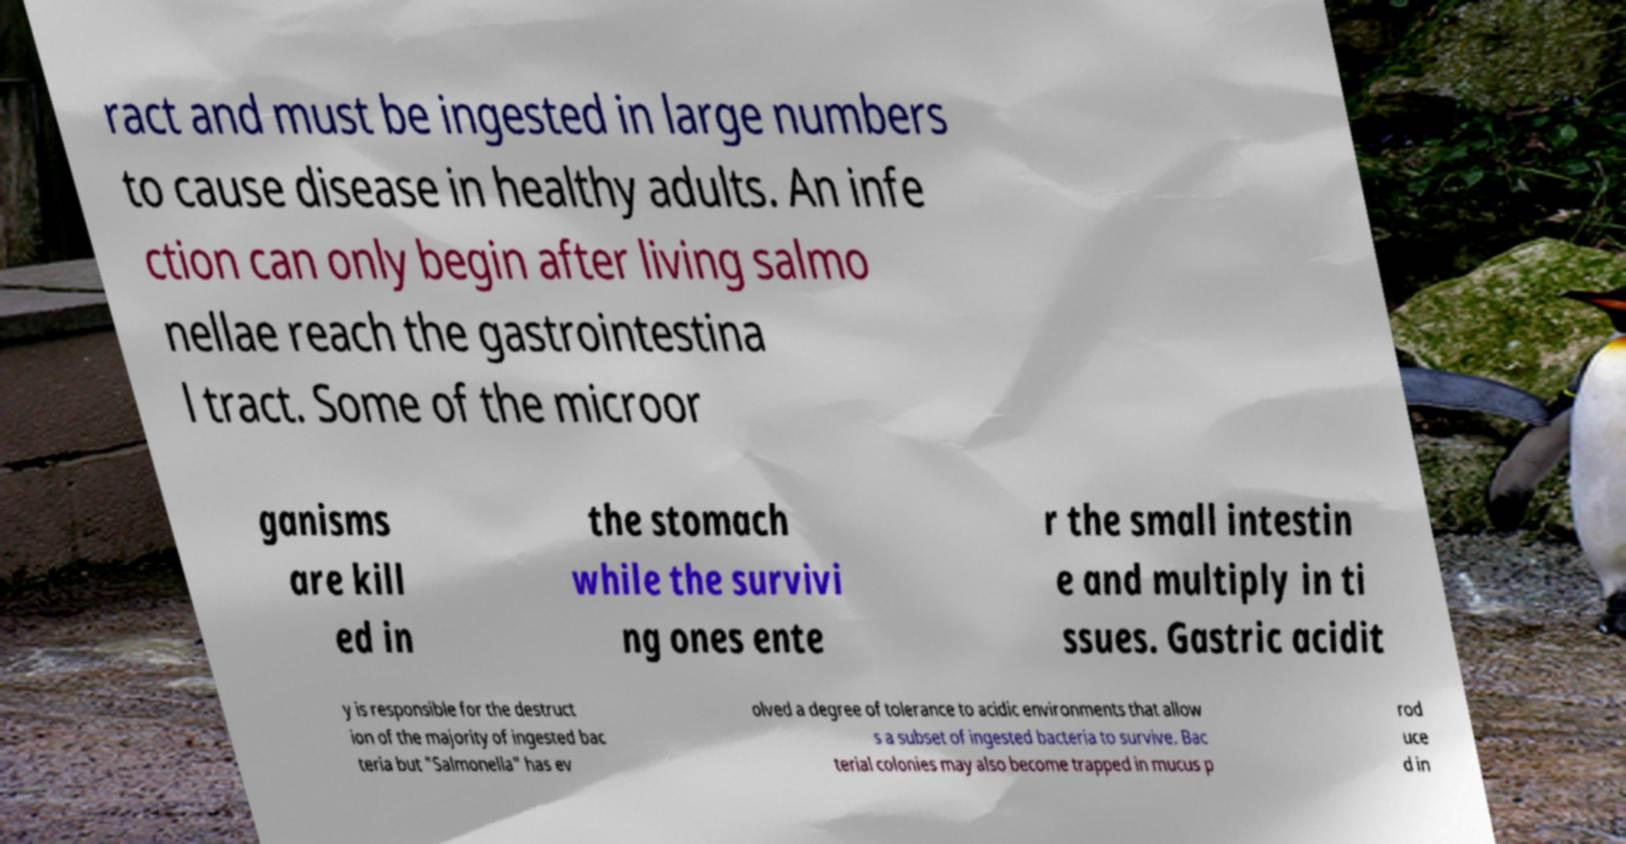Please read and relay the text visible in this image. What does it say? ract and must be ingested in large numbers to cause disease in healthy adults. An infe ction can only begin after living salmo nellae reach the gastrointestina l tract. Some of the microor ganisms are kill ed in the stomach while the survivi ng ones ente r the small intestin e and multiply in ti ssues. Gastric acidit y is responsible for the destruct ion of the majority of ingested bac teria but "Salmonella" has ev olved a degree of tolerance to acidic environments that allow s a subset of ingested bacteria to survive. Bac terial colonies may also become trapped in mucus p rod uce d in 